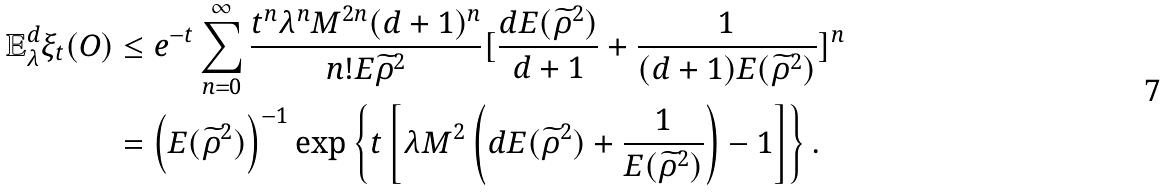Convert formula to latex. <formula><loc_0><loc_0><loc_500><loc_500>\mathbb { E } _ { \lambda } ^ { d } \xi _ { t } ( O ) & \leq e ^ { - t } \sum _ { n = 0 } ^ { \infty } \frac { t ^ { n } \lambda ^ { n } M ^ { 2 n } ( d + 1 ) ^ { n } } { n ! E { \widetilde { \rho } } ^ { 2 } } [ \frac { d E ( { \widetilde { \rho } } ^ { 2 } ) } { d + 1 } + \frac { 1 } { ( d + 1 ) E ( { \widetilde { \rho } } ^ { 2 } ) } ] ^ { n } \\ & = \left ( E ( { \widetilde { \rho } } ^ { 2 } ) \right ) ^ { - 1 } \exp \left \{ t \left [ \lambda M ^ { 2 } \left ( d E ( { \widetilde { \rho } } ^ { 2 } ) + \frac { 1 } { E ( { \widetilde { \rho } } ^ { 2 } ) } \right ) - 1 \right ] \right \} .</formula> 